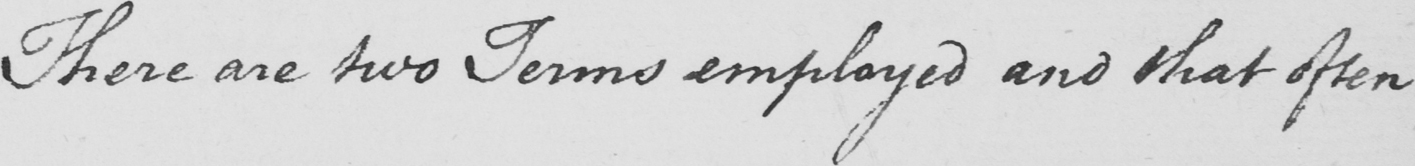Please transcribe the handwritten text in this image. There are two Terms employed and that often 